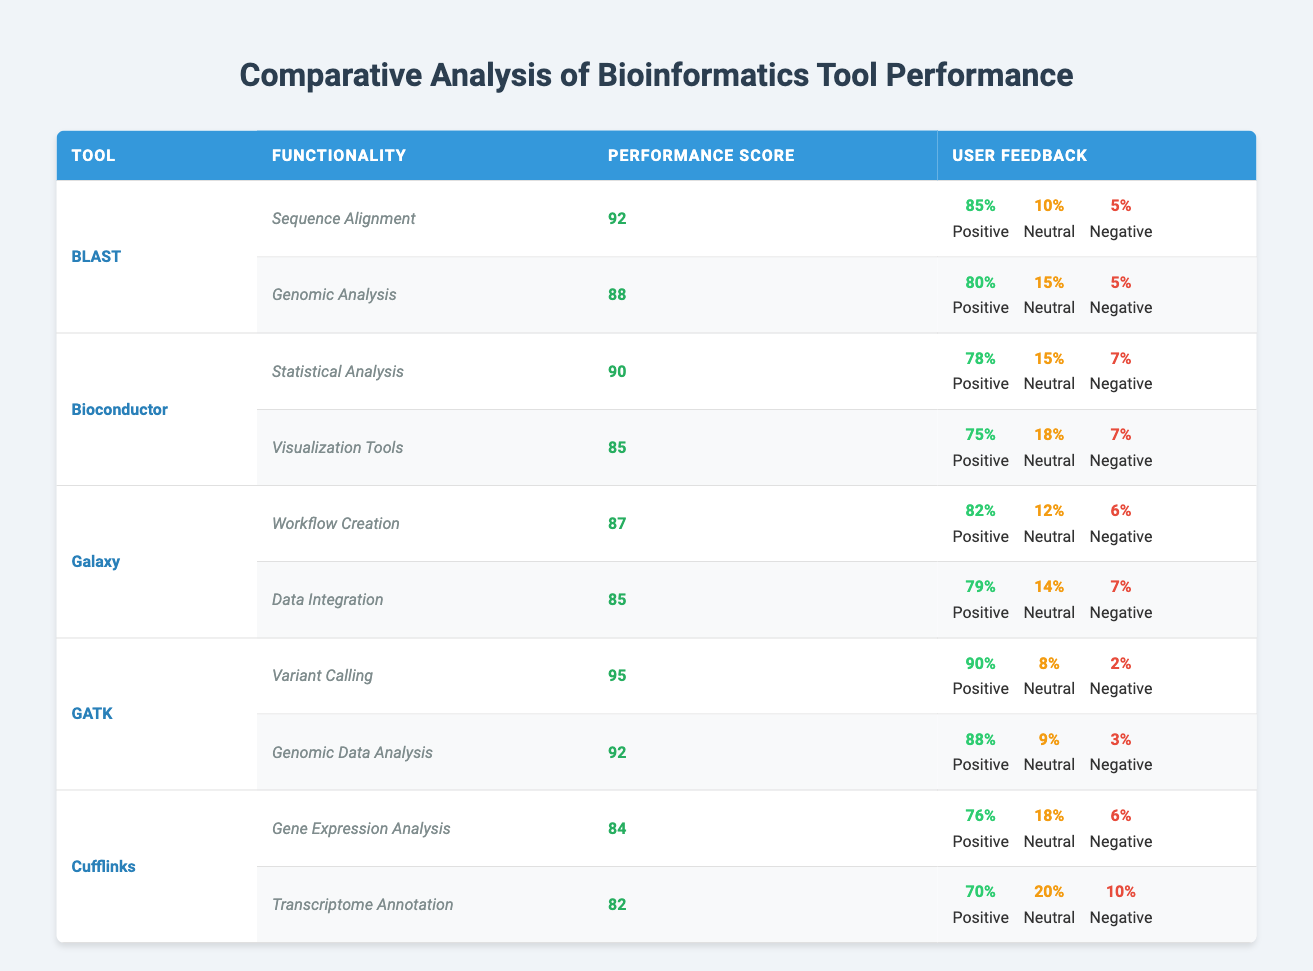What is the performance score of GATK for variant calling? GATK's performance score for the functionality "Variant Calling" is explicitly listed in the table, and it states 95.
Answer: 95 Which tool has the highest positive user feedback percentage in genomic data analysis? GATK has the highest positive user feedback percentage in the "Genomic Data Analysis" functionality, which is 88%, while the others are lower.
Answer: GATK What is the average performance score of all tools for their respective functionalities? The performance scores are: BLAST (90), Bioconductor (87.5), Galaxy (86), GATK (93.5), Cufflinks (83). The average is calculated as (92 + 88 + 90 + 85 + 87 + 95 + 92 + 84 + 82) = 89.4, then 89.4/9 = 89.4.
Answer: 89.4 Does Bioconductor receive more positive feedback than Galaxy in any functionality? For "Statistical Analysis", Bioconductor has 78% positive feedback, while Galaxy has only 82% for "Workflow Creation". Thus, Galaxy receives more positive feedback than Bioconductor overall.
Answer: No What is the total percentage of neutral feedback for all functionalities of Cufflinks? For Cufflinks, the neutral feedback percentages are 18% for "Gene Expression Analysis" and 20% for "Transcriptome Annotation". Adding these gives a total of 18 + 20 = 38%.
Answer: 38% 